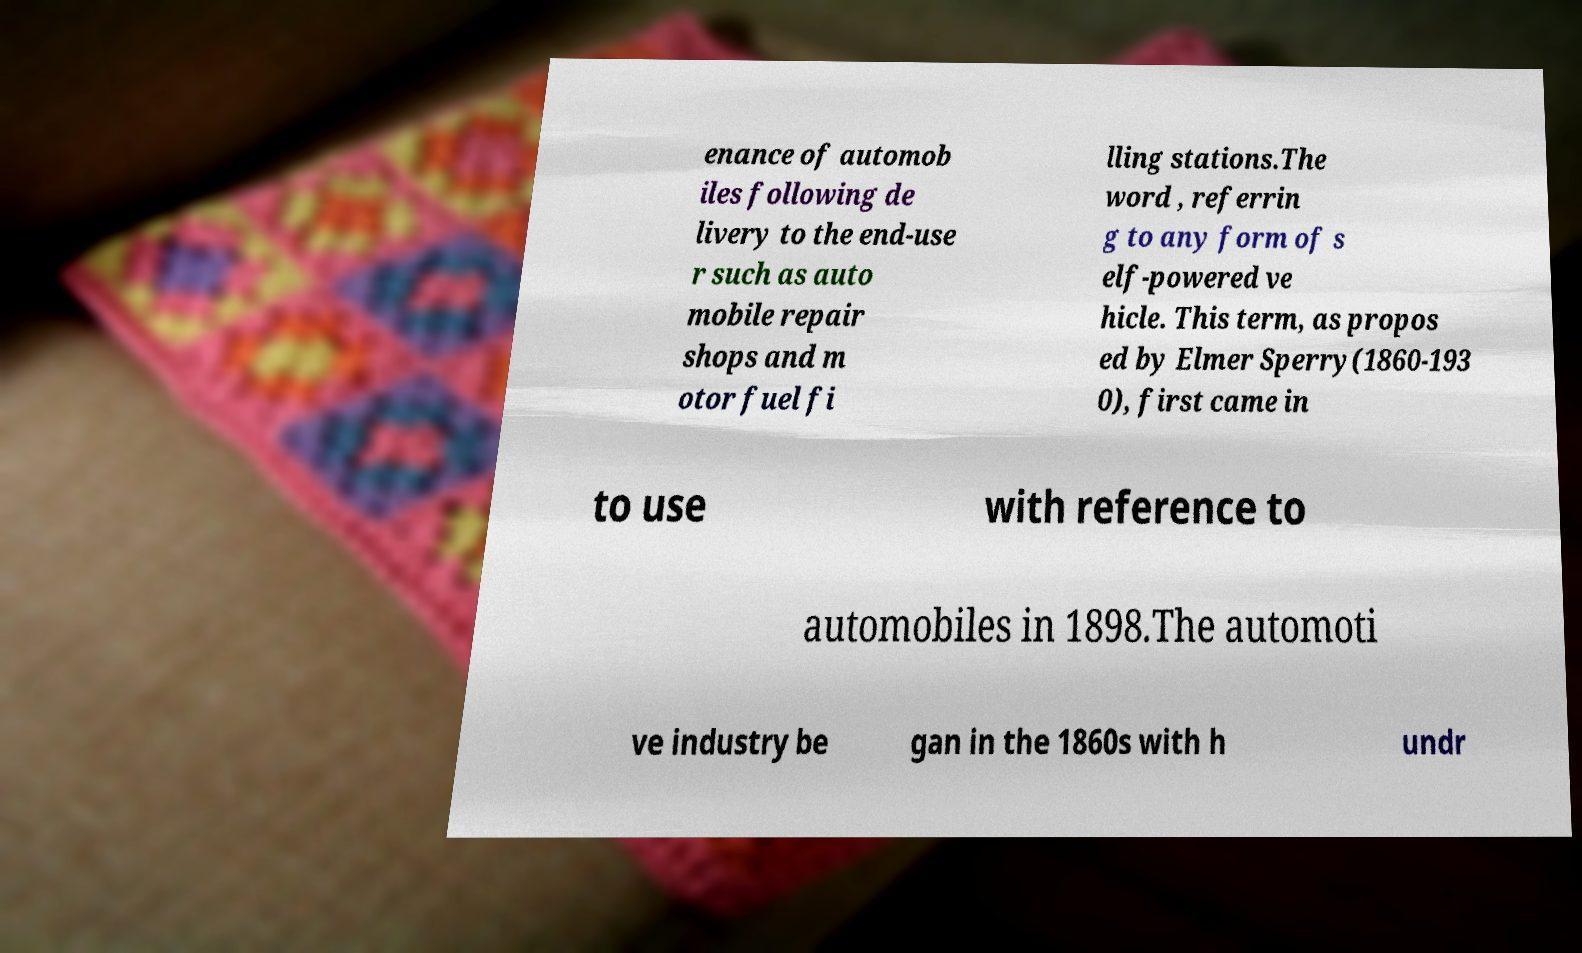For documentation purposes, I need the text within this image transcribed. Could you provide that? enance of automob iles following de livery to the end-use r such as auto mobile repair shops and m otor fuel fi lling stations.The word , referrin g to any form of s elf-powered ve hicle. This term, as propos ed by Elmer Sperry(1860-193 0), first came in to use with reference to automobiles in 1898.The automoti ve industry be gan in the 1860s with h undr 